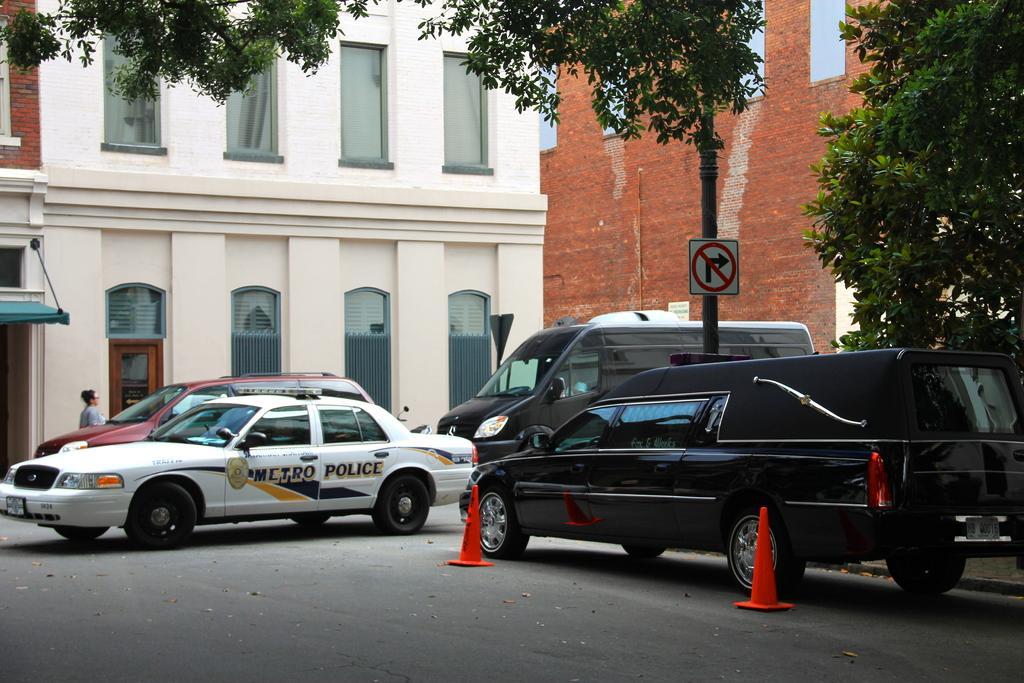Can you describe this image briefly? In this image we can see vehicles, traffic cones, road, person, building and trees. 